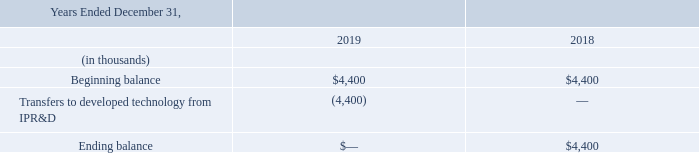Indefinite-lived Intangible Assets
Indefinite-lived intangible assets consist entirely of acquired in-process research and development technology, or IPR&D. The following table sets forth the Company’s activities related to the indefinite-lived intangible assets:
The Company performs its annual assessment of indefinite-lived intangible assets on October 31 each year or more frequently if events or changes in circumstances indicate that the asset might be impaired utilizing a qualitative test as a precursor to the quantitative test comparing the fair value of the assets with their carrying amount. Based on the qualitative test, if it is more likely than not that indicators of impairment exists, the Company proceeds to perform a quantitative analysis. Based on the Company’s assessment as of October 31, 2019, no indicators of impairment were identified.
In the years ended December 31, 2019 and 2018, no IPR&D impairment losses were recorded. In the year ended December 31, 2017, the Company recognized impairment losses of $2.0 million related to the Company's abandonment of a single IPR&D project.
When does the company perform its annual assessment? October 31. What was the impairment loss recognized by the company in 2017? $2.0 million. What were the Transfers to developed technology from IPR&D in 2019 and 2018 respectively?
Answer scale should be: thousand. (4,400), 0. What was the change in the Transfers to developed technology from IPR&D from 2018 to 2019?
Answer scale should be: thousand. -4,400 - 0
Answer: -4400. What is the average ending balance for 2018 and 2019?
Answer scale should be: thousand. (0 + 4,400) / 2
Answer: 2200. In which year was Transfers to developed technology from IPR&D negative? Locate and analyze transfers to developed technology from ipr&d in row 5
answer: 2019. 